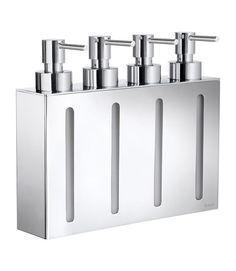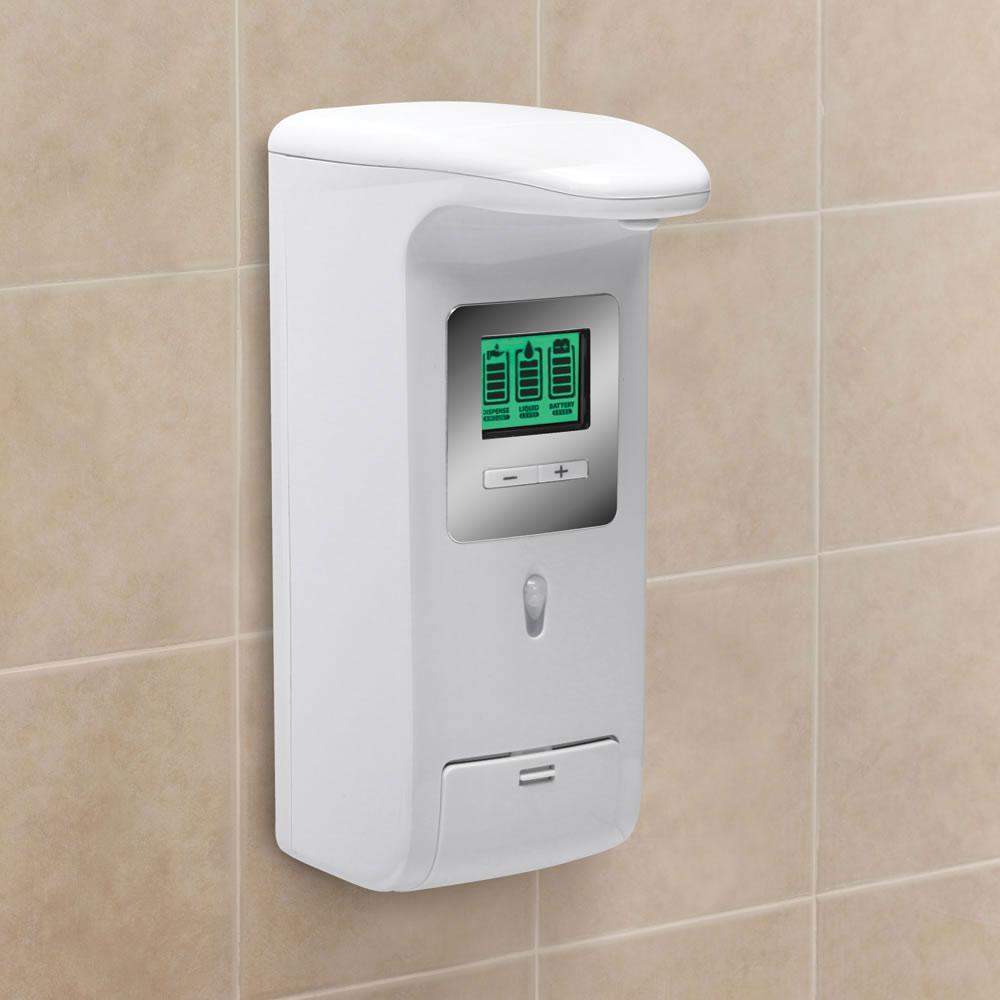The first image is the image on the left, the second image is the image on the right. Analyze the images presented: Is the assertion "One of the images shows a dispenser for two liquids, lotions, or soaps." valid? Answer yes or no. No. The first image is the image on the left, the second image is the image on the right. Given the left and right images, does the statement "In one image there are two dispensers with a silver base." hold true? Answer yes or no. No. 